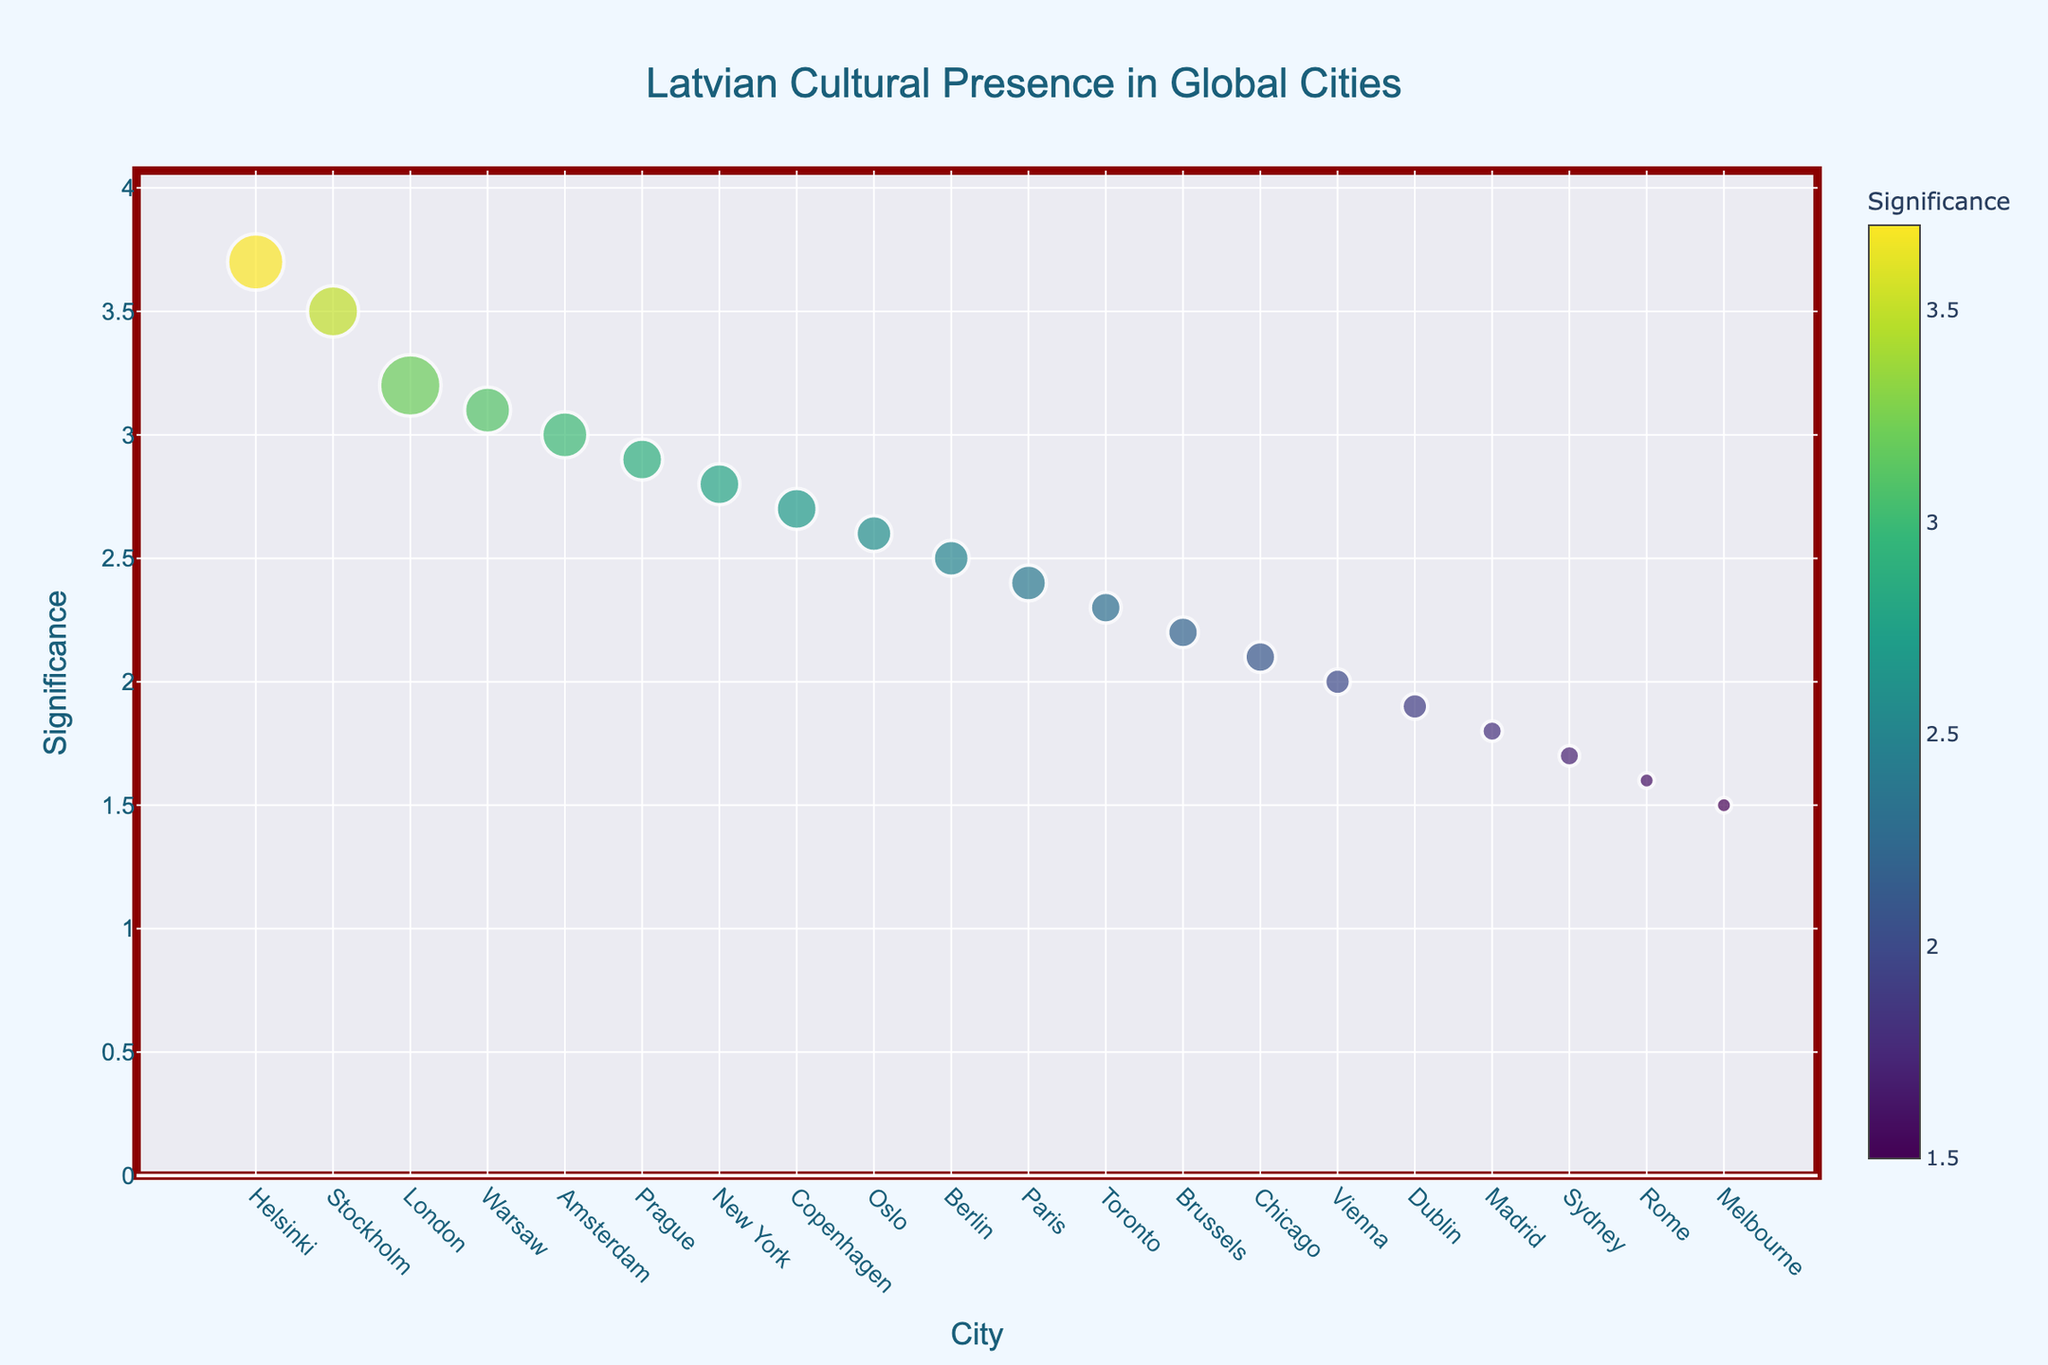What's the city with the highest significance for Latvian cultural events? The city with the highest significance is identified by the topmost point on the y-axis indicating "Significance". The highest significance on the plot is for Helsinki with a value of 3.7.
Answer: Helsinki Which city hosts the most Latvian cultural events per year? To find the city hosting the most events per year, you need to look for the largest marker on the plot. Helsinki hosts the most events per year, with 11 events.
Answer: Helsinki Between London and New York, which city has a higher significance for Latvian cultural events? Compare the y-axis "Significance" values for both cities. London has a significance of 3.2, whereas New York has a significance of 2.8. Therefore, London has a higher significance.
Answer: London What's the average significance of the cities with more than 7 events per year? First, identify the cities with more than 7 events per year: London, Stockholm, Amsterdam, Warsaw, Helsinki. Their significance values are 3.2, 3.5, 3.0, 3.1, 3.7 respectively. Average is (3.2 + 3.5 + 3.0 + 3.1 + 3.7) / 5 = 3.3.
Answer: 3.3 How does the significance of Melbourne compare to Sydney? Melbourne has a significance of 1.5, while Sydney has a significance of 1.7. Therefore, Melbourne has a lower significance compared to Sydney.
Answer: Sydney Which city has the smallest number of Latvian cultural events per year, and what is its significance? The smallest marker corresponds to Melbourne and Rome, both hosting 3 events per year. Their significance values are 1.5 and 1.6 respectively.
Answer: Melbourne (1.5), Rome (1.6) Is there any city with exactly 8 events per year, and if so, what's its significance? Cities with 8 events per year are highlighted in the plot, and they are New York, Copenhagen, and Prague. Their significance values are 2.8, 2.7, and 2.9 respectively.
Answer: New York (2.8), Copenhagen (2.7), Prague (2.9) Which has a higher significance, Berlin or Oslo? Find Berlin and Oslo on the plot; Berlin has a significance of 2.5, while Oslo has a significance of 2.6. Oslo has a higher significance.
Answer: Oslo What is the range of significance values displayed on the plot? The range of the significance values is determined by the minimum and maximum values shown on the y-axis. The minimum value is around 1.5 and the maximum value is 3.7.
Answer: 1.5 to 3.7 Do any cities have more than 6 events per year and a significance lower than 2.2? If so, name them. Check all markers with more than 6 events and see their significance level. London, New York, Berlin, Toronto, Stockholm, Paris, Amsterdam, Copenhagen, Oslo, Helsinki, Warsaw, Prague do not fit the criteria as they all have significances greater than 2.2. No cities meet this criteria.
Answer: No 